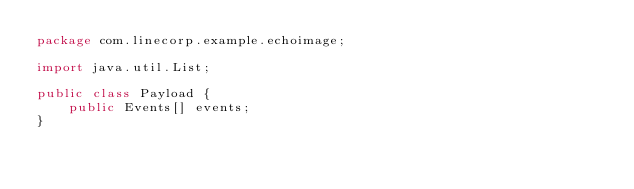Convert code to text. <code><loc_0><loc_0><loc_500><loc_500><_Java_>package com.linecorp.example.echoimage;

import java.util.List;

public class Payload {
    public Events[] events;
}
</code> 